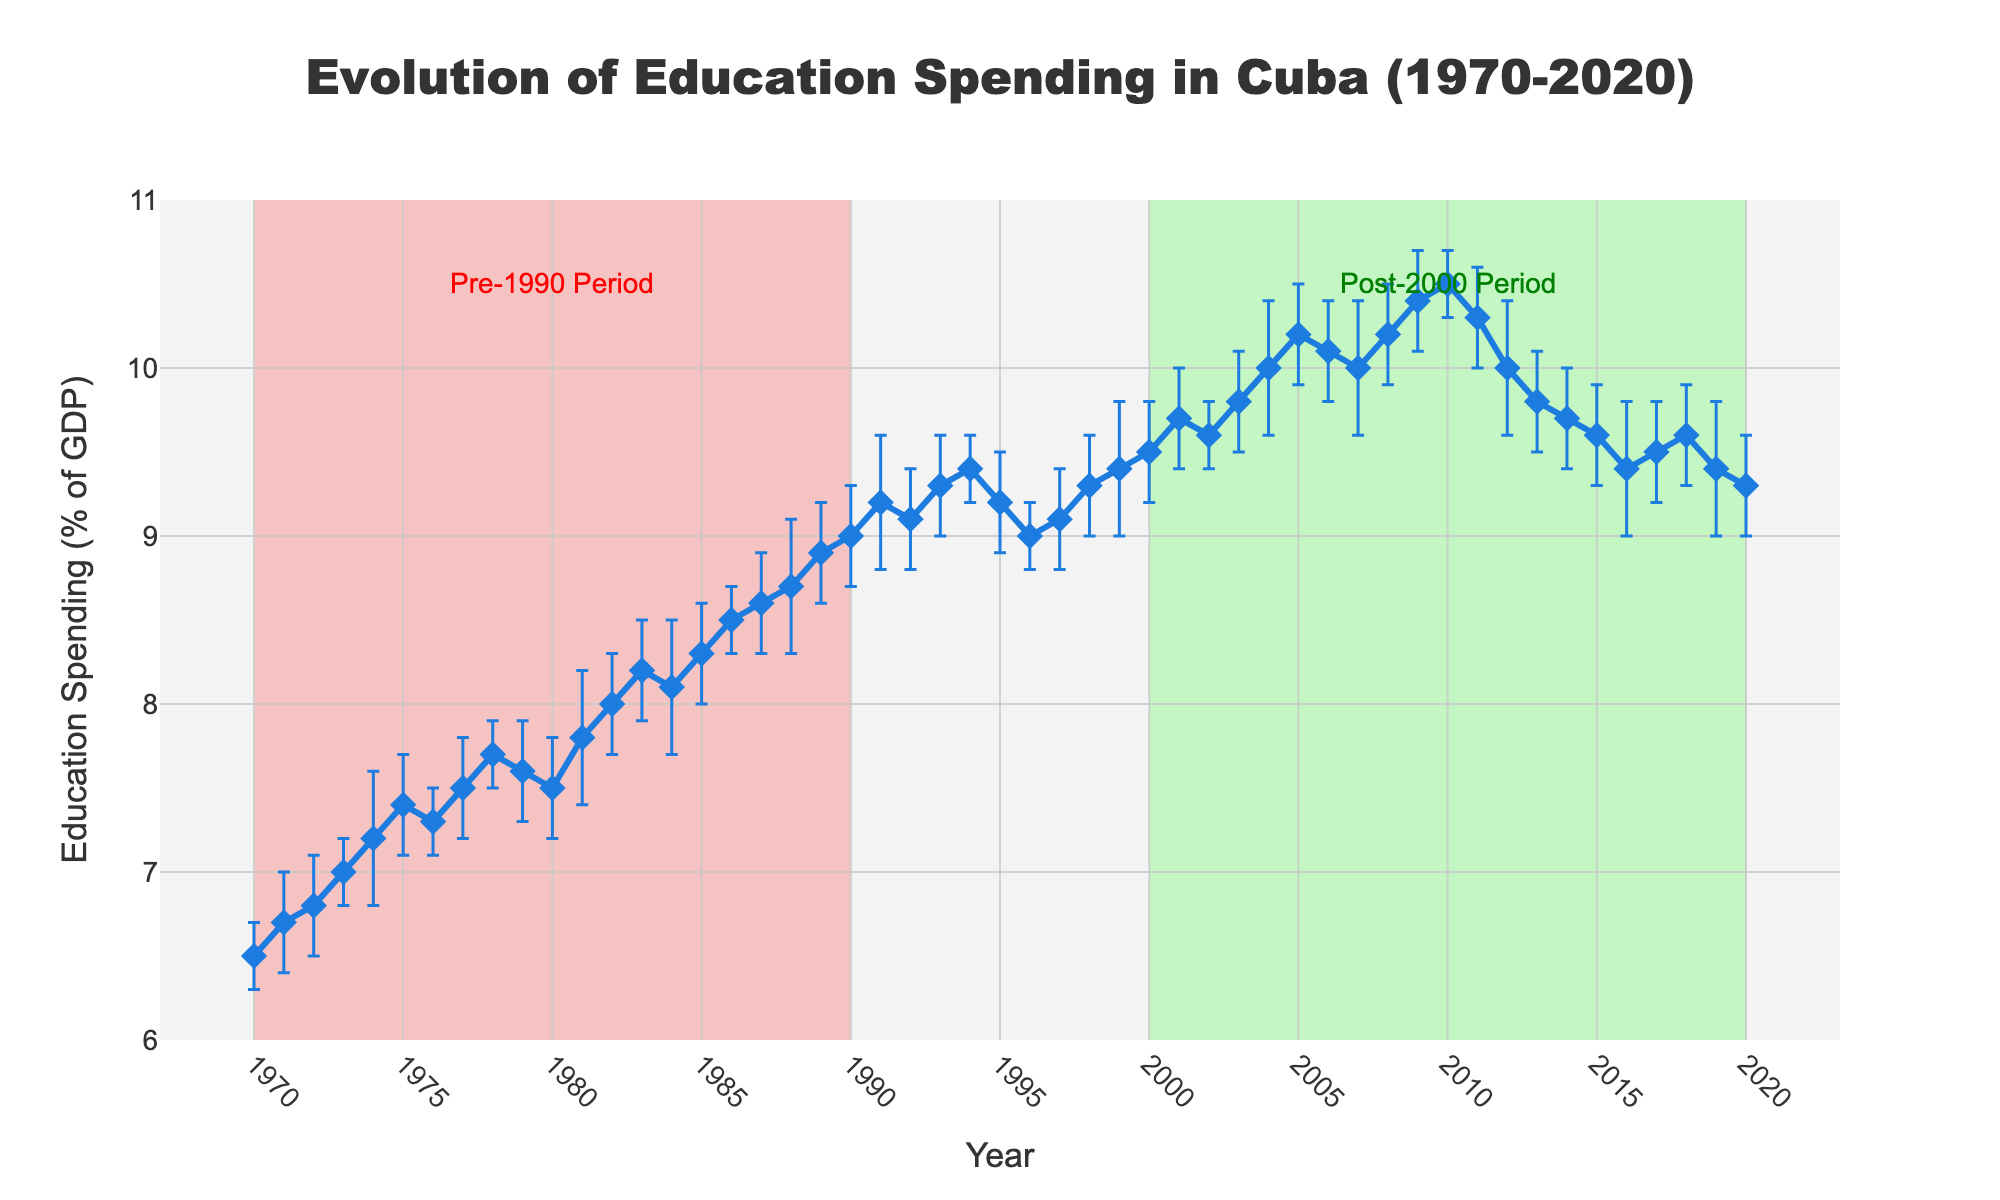What is the title of the plot? The title of the plot is prominently displayed at the top of the figure in bold font. It reads, "Evolution of Education Spending in Cuba (1970-2020)".
Answer: Evolution of Education Spending in Cuba (1970-2020) What does the y-axis represent, and what is its range? The y-axis represents the percentage of GDP spent on education in Cuba. The axis starts at 6% and goes up to 11%. This is indicated by the y-axis label "Education Spending (% of GDP)" and the tick marks ranging from 6 to 11.
Answer: Education Spending (% of GDP), range 6 to 11 In which year did Cuba reach its peak education spending, and what was the percentage? To find the peak spending, look for the highest point on the line plot. The highest point is in 2010, where the spending reached 10.5% of GDP.
Answer: 2010, 10.5% Compare the education spending in 1970 and 2020. Which year had a higher percentage, and by how much? In 1970, the education spending was 6.5% of GDP. In 2020, it was 9.3% of GDP. Subtracting these values, 2020 had a higher percentage by 9.3 - 6.5 = 2.8%.
Answer: 2020, by 2.8% What can be inferred about the education spending trend before and after the year 2000? The plot shows a general increasing trend in education spending as a percentage of GDP before 2000. Post-2000, there is a fluctuation with a peak in 2010 and a slight decline thereafter. This visual trend is further highlighted by the green rectangular shape for the post-2000 period and the red rectangular shape for the pre-1990 period.
Answer: Increasing before 2000, fluctuates after 2000 What was the average education spending as a percentage of GDP in the decade 1980-1989? To calculate the average, add the percentages for each year from 1980 to 1989 and divide by 10. The values are: 7.5, 7.8, 8.0, 8.2, 8.1, 8.3, 8.5, 8.6, 8.7, 8.9. Summing them gives 82.6. Thus, the average is 82.6 / 10 = 8.26%.
Answer: 8.26% Which year had the highest yearly variability in education spending, and what was the standard deviation? To identify the highest variability, look for the largest error bar. The year 1974 shows the highest error bar, indicating a standard deviation of 0.4.
Answer: 1974, 0.4 Was there any year in the plot where education spending decreased compared to the previous year? To identify years with a decrease, look for points where the line dips downwards. It decreased from 1984 to 1985 (8.2 to 8.1), from 2011 to 2012 (10.3 to 10.0), from 2012 to 2013 (10.0 to 9.8), from 2013 to 2014 (9.8 to 9.7), from 2014 to 2015 (9.7 to 9.6), and from 2018 to 2019 (9.6 to 9.4).
Answer: 1984-1985, 2011-2012, 2012-2013, 2013-2014, 2014-2015, 2018-2019 What are the two significant periods highlighted in the plot, and what colors are used to indicate them? The plot highlights two periods: the pre-1990 period and the post-2000 period. The pre-1990 period is shaded in a light red color, and the post-2000 period is shaded in a light green color.
Answer: Pre-1990 (red), Post-2000 (green) What is the difference in education spending as a percentage of GDP between 2004 and 2005? The education spending in 2004 was 10.0%, and in 2005 it was 10.2%. Subtracting these values gives a difference of 10.2 - 10.0 = 0.2%.
Answer: 0.2% 